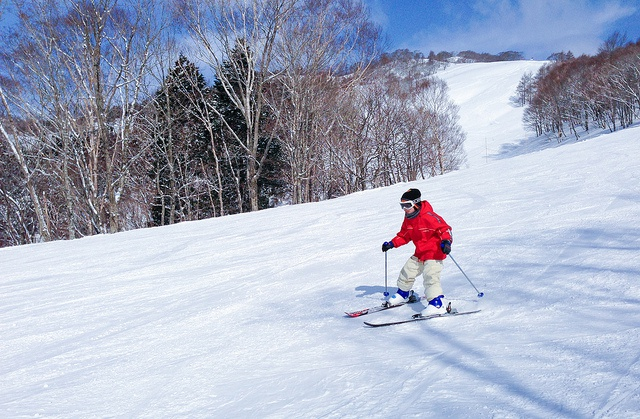Describe the objects in this image and their specific colors. I can see people in gray, lightgray, brown, and darkgray tones and skis in gray, darkgray, and black tones in this image. 